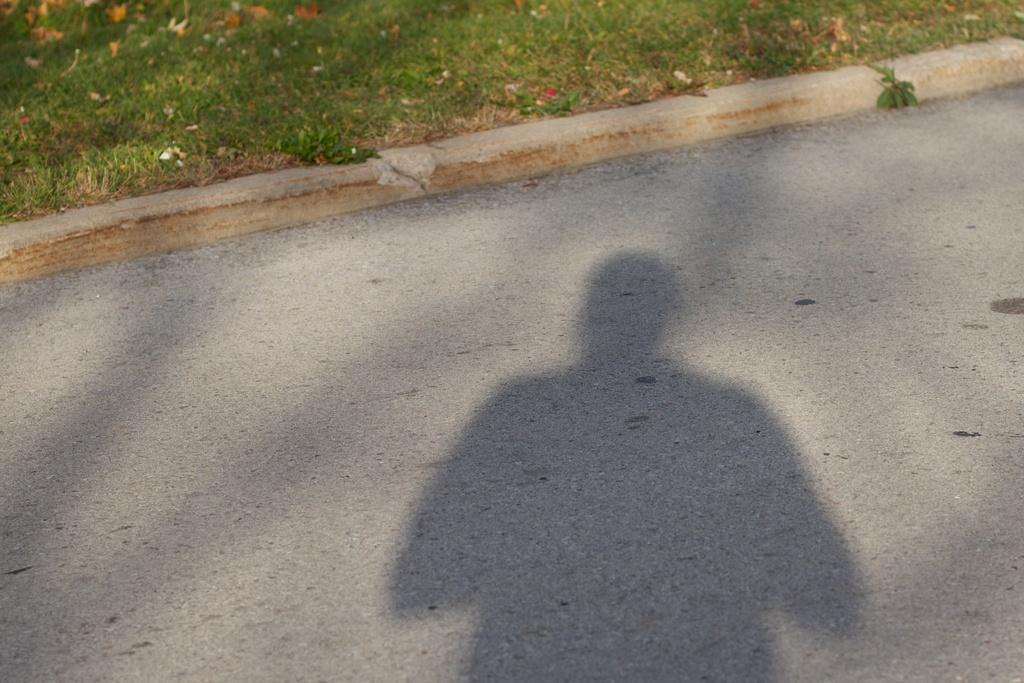What type of shadows can be seen on the road in the image? There are shadows of trees and a person on the road in the image. What is the ground surface like in the image? The ground surface is covered with grass. Are there any structures visible in the image? Yes, there is a small wall in the image. What type of pet is the mother holding in the image? There is no pet or mother present in the image; it only features shadows of trees and a person on the road. Can you describe the beetle crawling on the small wall in the image? There is no beetle present on the small wall in the image. 